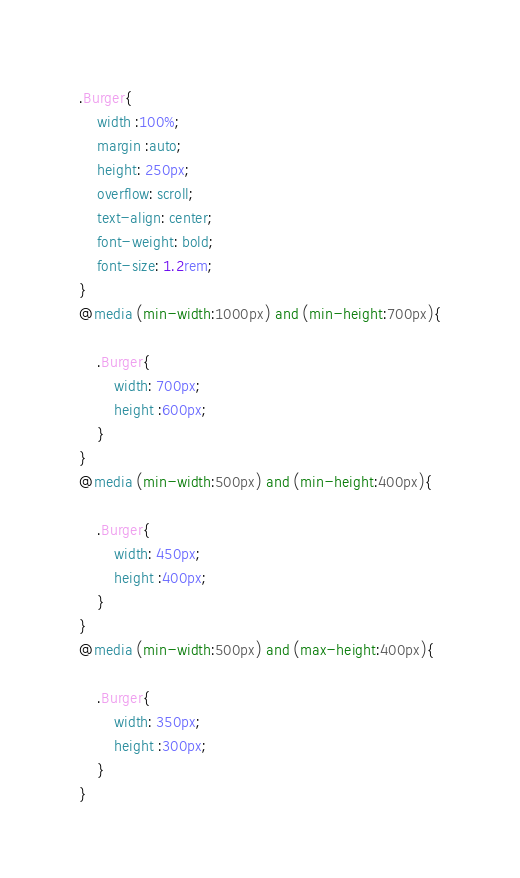<code> <loc_0><loc_0><loc_500><loc_500><_CSS_>.Burger{
    width :100%;
    margin :auto;
    height: 250px;
    overflow: scroll;
    text-align: center;
    font-weight: bold;
    font-size: 1.2rem;
}
@media (min-width:1000px) and (min-height:700px){

    .Burger{
        width: 700px;
        height :600px;
    }
}
@media (min-width:500px) and (min-height:400px){

    .Burger{
        width: 450px;
        height :400px;
    }
}
@media (min-width:500px) and (max-height:400px){

    .Burger{
        width: 350px;
        height :300px;
    }
}</code> 